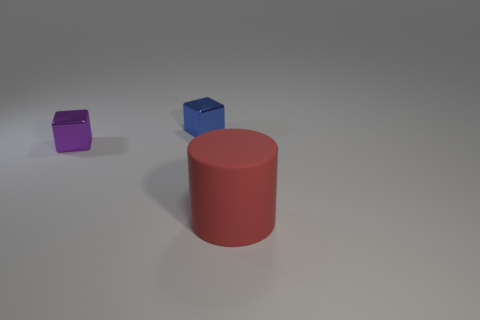Can you speculate on the material of the objects? Based on the reflections and textures, the objects seem to be made of a matte metal, which gives them a realistic and tangible quality. This is especially evident considering the soft light highlights and the solidity of their forms. 